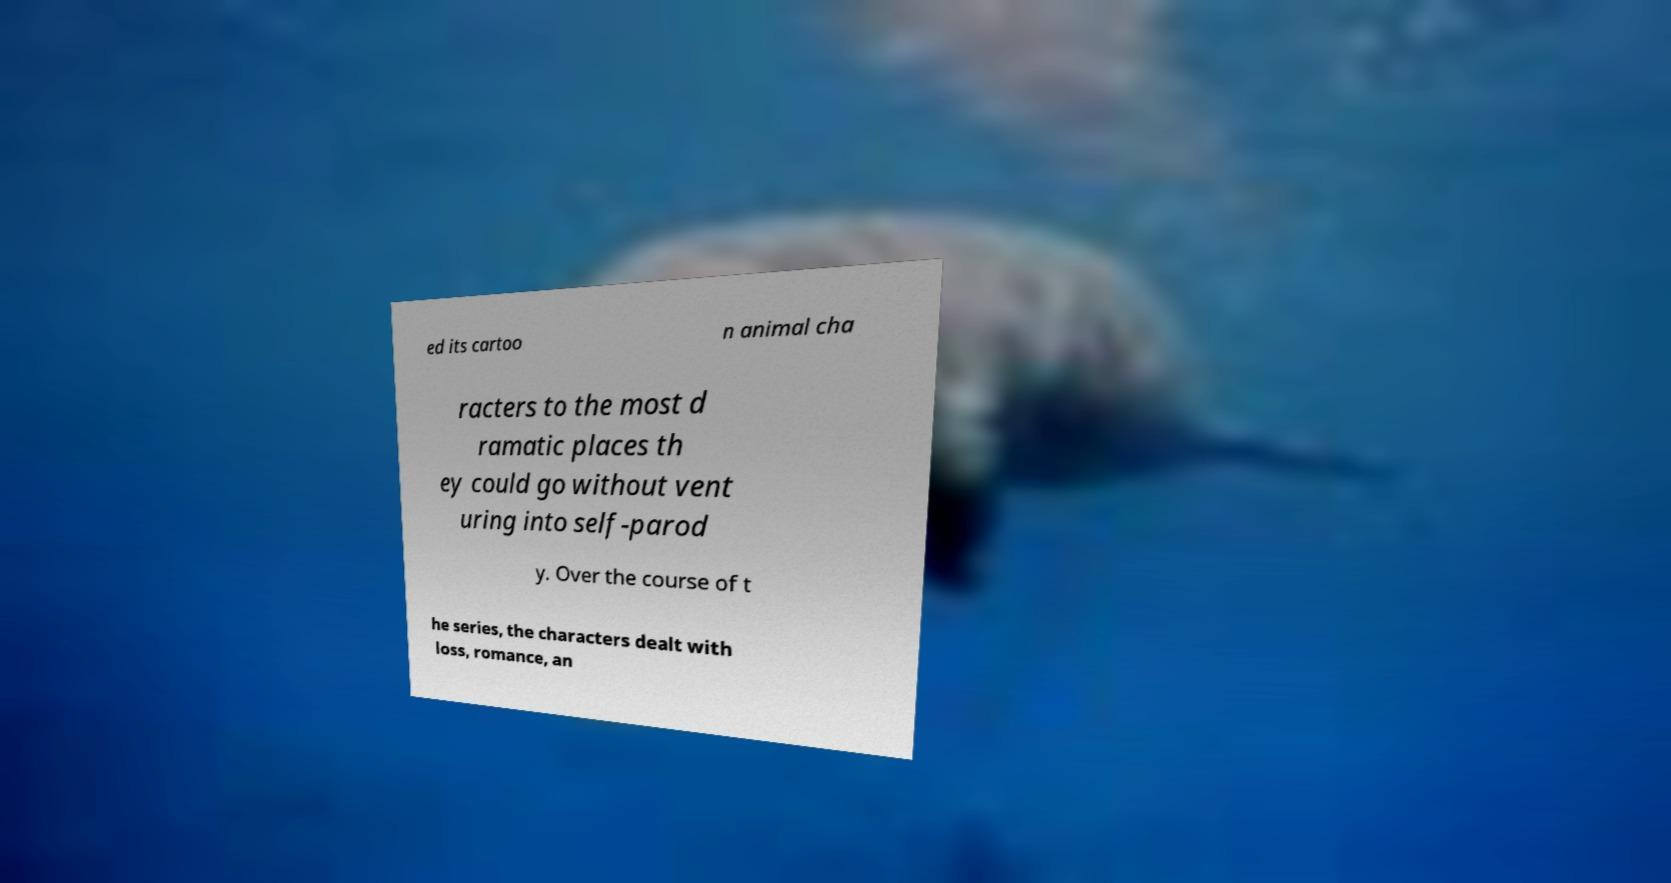Could you extract and type out the text from this image? ed its cartoo n animal cha racters to the most d ramatic places th ey could go without vent uring into self-parod y. Over the course of t he series, the characters dealt with loss, romance, an 